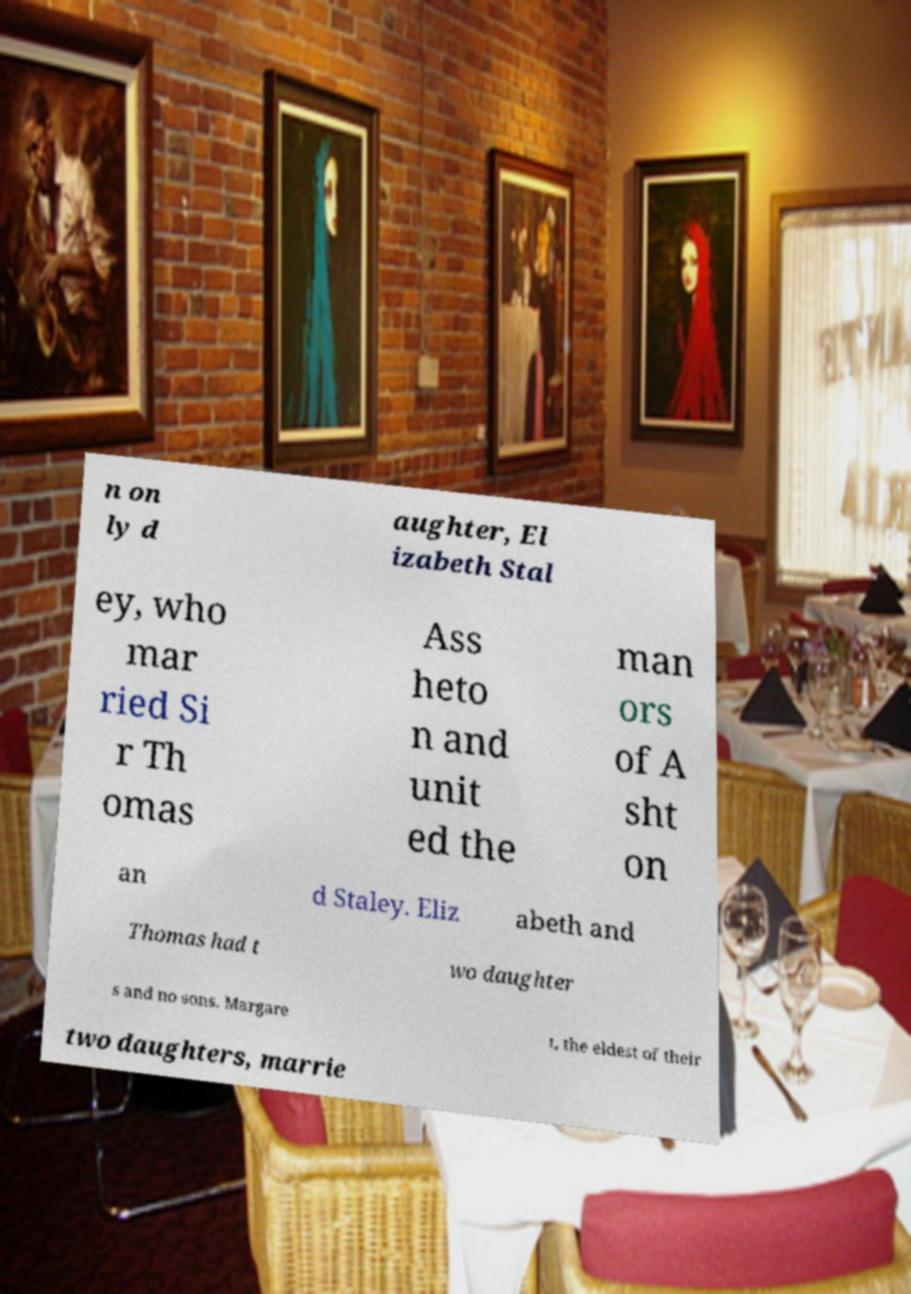Could you assist in decoding the text presented in this image and type it out clearly? n on ly d aughter, El izabeth Stal ey, who mar ried Si r Th omas Ass heto n and unit ed the man ors of A sht on an d Staley. Eliz abeth and Thomas had t wo daughter s and no sons. Margare t, the eldest of their two daughters, marrie 